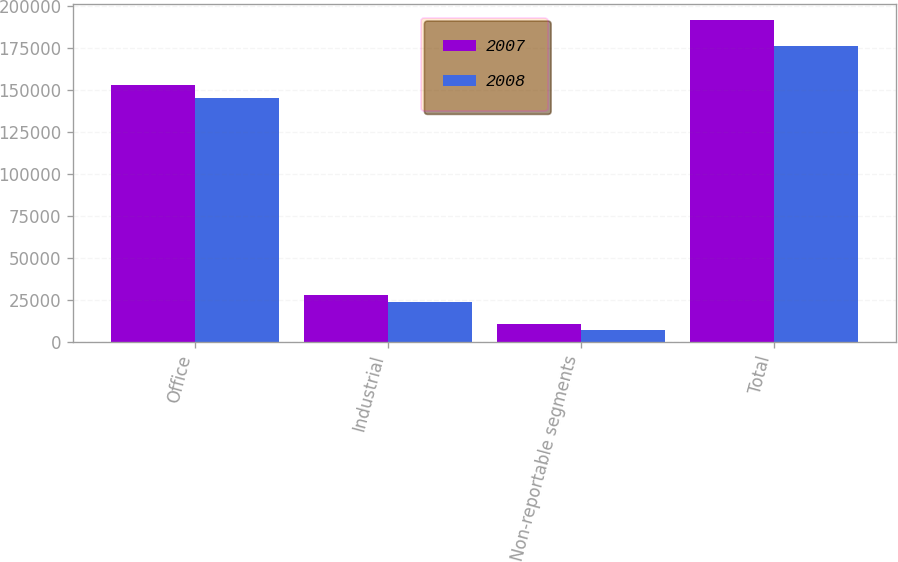Convert chart. <chart><loc_0><loc_0><loc_500><loc_500><stacked_bar_chart><ecel><fcel>Office<fcel>Industrial<fcel>Non-reportable segments<fcel>Total<nl><fcel>2007<fcel>152856<fcel>27703<fcel>10705<fcel>191264<nl><fcel>2008<fcel>145214<fcel>23819<fcel>7003<fcel>176036<nl></chart> 